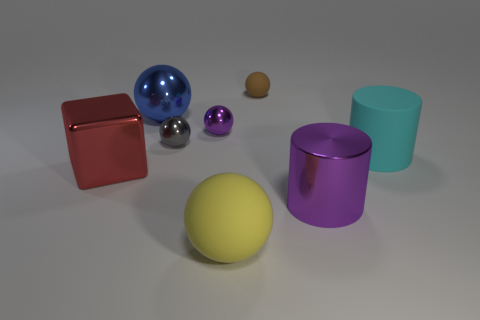Does the shiny cylinder have the same color as the small shiny sphere that is to the right of the gray ball?
Offer a very short reply. Yes. There is a small ball that is the same color as the metal cylinder; what is it made of?
Provide a short and direct response. Metal. There is a tiny shiny object behind the tiny gray shiny object; is its color the same as the metal cylinder?
Your answer should be compact. Yes. Is there anything else that is the same color as the big shiny cylinder?
Ensure brevity in your answer.  Yes. There is a large shiny cylinder to the right of the tiny brown rubber ball; is its color the same as the metallic sphere that is on the right side of the small gray sphere?
Your answer should be very brief. Yes. The purple shiny object that is the same size as the brown matte thing is what shape?
Make the answer very short. Sphere. Are there any other objects of the same shape as the cyan object?
Your response must be concise. Yes. Do the large sphere that is right of the purple ball and the small sphere that is right of the small purple metal thing have the same material?
Provide a short and direct response. Yes. What is the shape of the metal object that is the same color as the shiny cylinder?
Offer a very short reply. Sphere. What number of purple cubes are made of the same material as the small brown object?
Your answer should be compact. 0. 